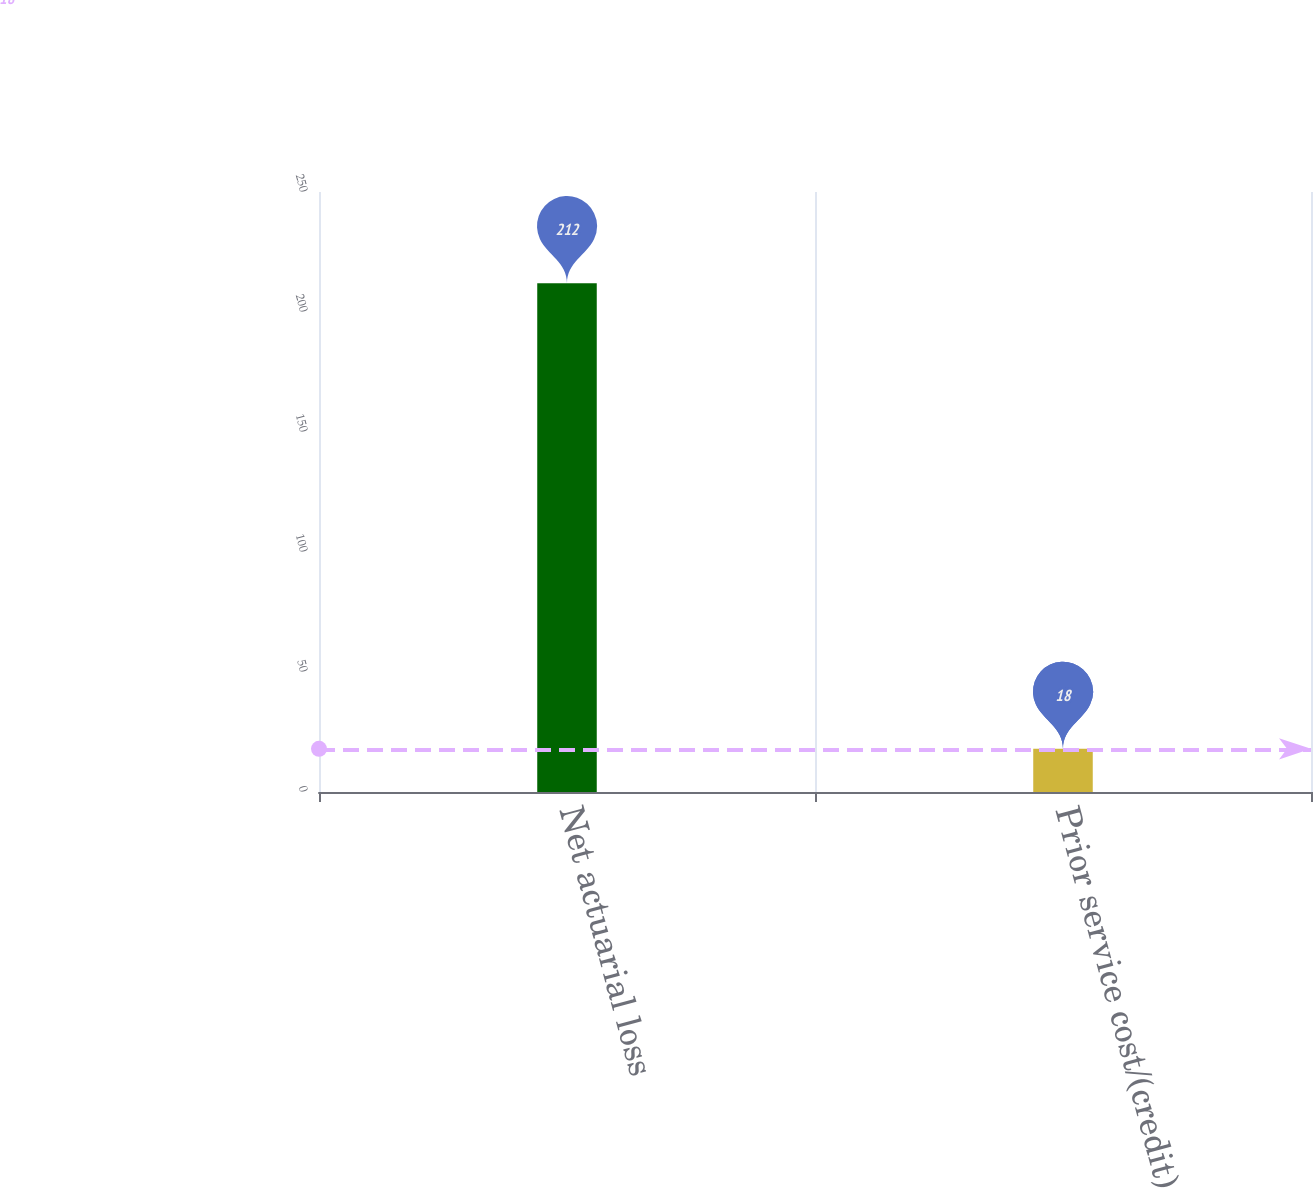Convert chart. <chart><loc_0><loc_0><loc_500><loc_500><bar_chart><fcel>Net actuarial loss<fcel>Prior service cost/(credit)<nl><fcel>212<fcel>18<nl></chart> 